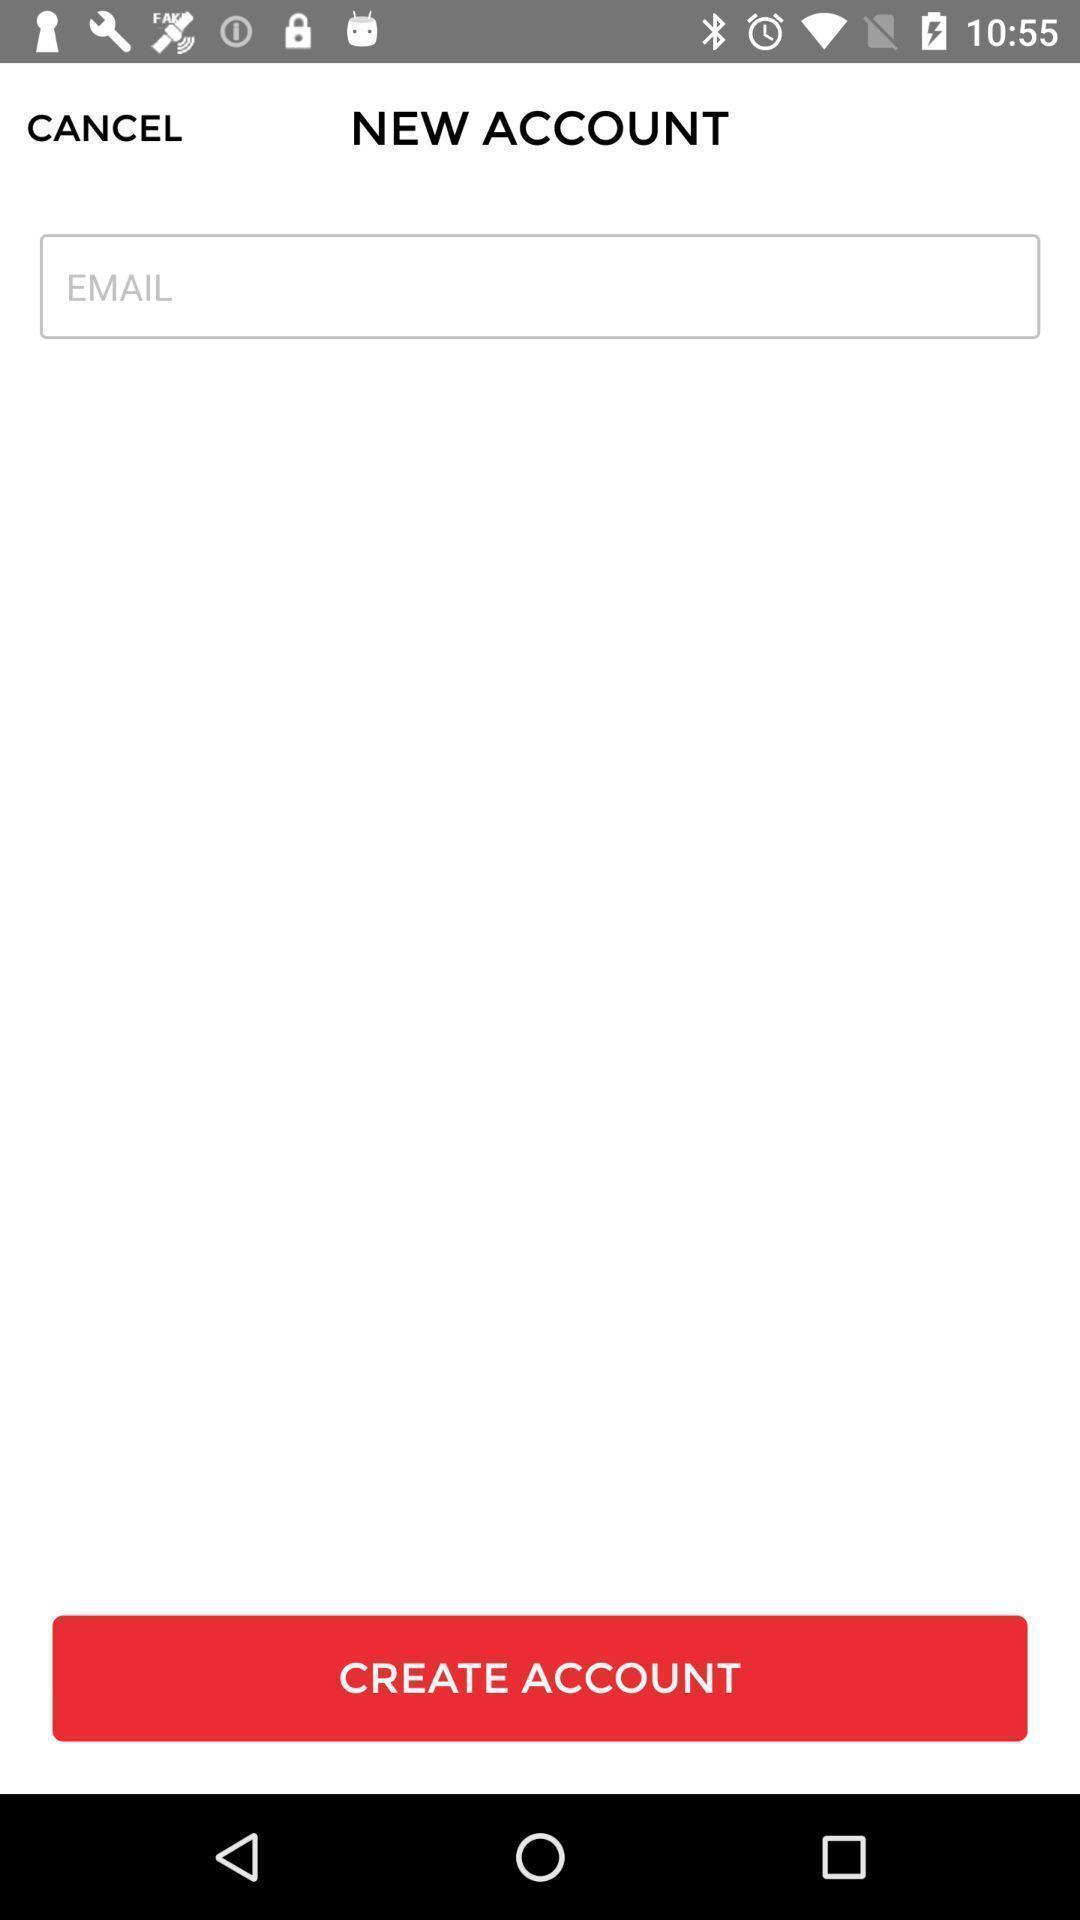Provide a textual representation of this image. Page showing input field to create account. 